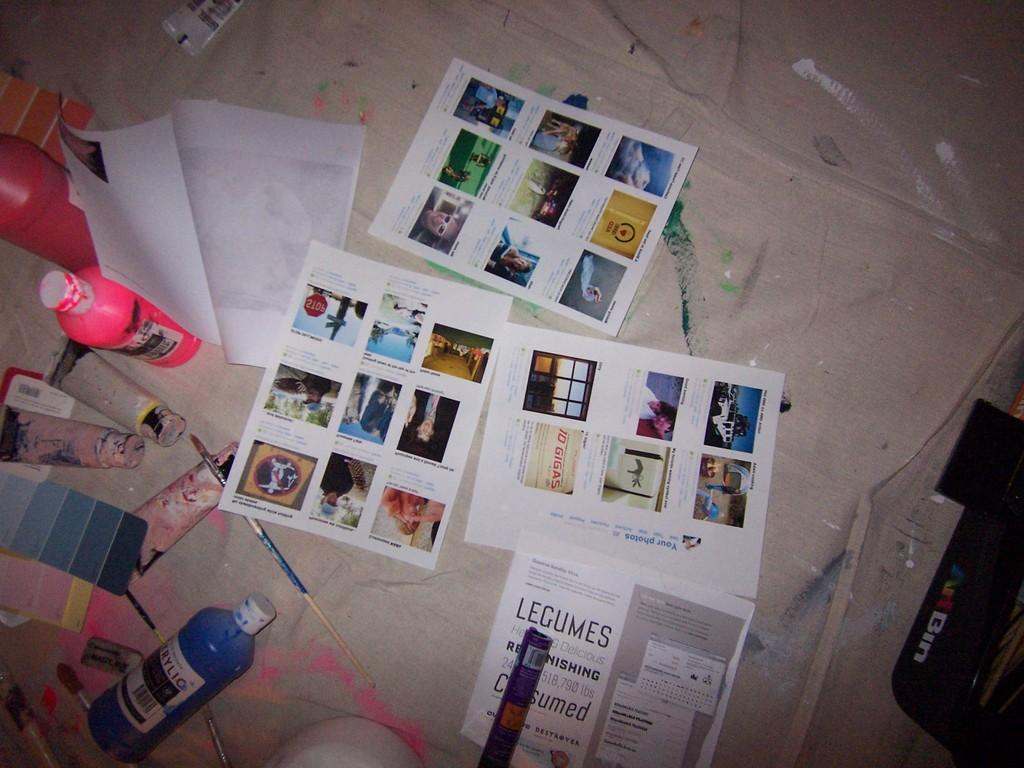Provide a one-sentence caption for the provided image. Paints and pictures from Legumes laying on the floor. 